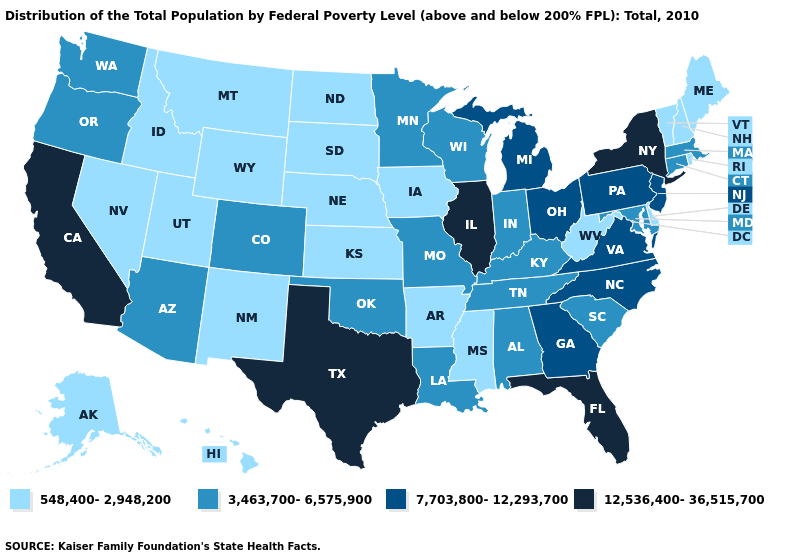Among the states that border Oklahoma , does Missouri have the highest value?
Be succinct. No. Does Vermont have the same value as Virginia?
Quick response, please. No. Name the states that have a value in the range 548,400-2,948,200?
Keep it brief. Alaska, Arkansas, Delaware, Hawaii, Idaho, Iowa, Kansas, Maine, Mississippi, Montana, Nebraska, Nevada, New Hampshire, New Mexico, North Dakota, Rhode Island, South Dakota, Utah, Vermont, West Virginia, Wyoming. What is the value of West Virginia?
Give a very brief answer. 548,400-2,948,200. What is the value of Connecticut?
Give a very brief answer. 3,463,700-6,575,900. What is the lowest value in states that border Ohio?
Quick response, please. 548,400-2,948,200. Which states have the lowest value in the USA?
Concise answer only. Alaska, Arkansas, Delaware, Hawaii, Idaho, Iowa, Kansas, Maine, Mississippi, Montana, Nebraska, Nevada, New Hampshire, New Mexico, North Dakota, Rhode Island, South Dakota, Utah, Vermont, West Virginia, Wyoming. Which states have the lowest value in the West?
Answer briefly. Alaska, Hawaii, Idaho, Montana, Nevada, New Mexico, Utah, Wyoming. Name the states that have a value in the range 12,536,400-36,515,700?
Concise answer only. California, Florida, Illinois, New York, Texas. What is the highest value in the USA?
Write a very short answer. 12,536,400-36,515,700. Does Illinois have the highest value in the USA?
Keep it brief. Yes. Among the states that border Texas , does Oklahoma have the lowest value?
Be succinct. No. Name the states that have a value in the range 548,400-2,948,200?
Write a very short answer. Alaska, Arkansas, Delaware, Hawaii, Idaho, Iowa, Kansas, Maine, Mississippi, Montana, Nebraska, Nevada, New Hampshire, New Mexico, North Dakota, Rhode Island, South Dakota, Utah, Vermont, West Virginia, Wyoming. Which states have the lowest value in the USA?
Keep it brief. Alaska, Arkansas, Delaware, Hawaii, Idaho, Iowa, Kansas, Maine, Mississippi, Montana, Nebraska, Nevada, New Hampshire, New Mexico, North Dakota, Rhode Island, South Dakota, Utah, Vermont, West Virginia, Wyoming. Which states hav the highest value in the Northeast?
Write a very short answer. New York. 